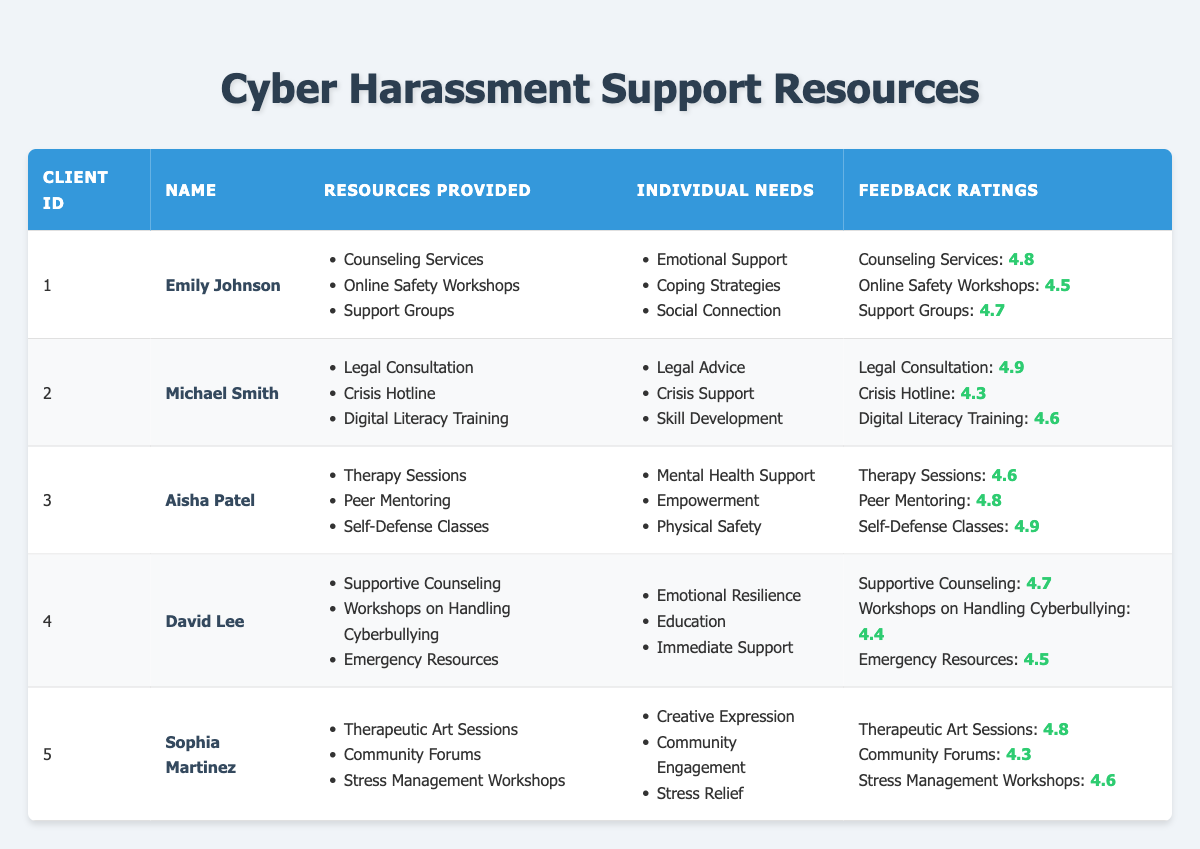What resources were provided to Emily Johnson? Emily Johnson is listed in the table with the resources provided as Counseling Services, Online Safety Workshops, and Support Groups.
Answer: Counseling Services, Online Safety Workshops, Support Groups What was the feedback rating for the Crisis Hotline? The table provides the feedback rating for the Crisis Hotline under Michael Smith's entry as 4.3.
Answer: 4.3 Which client received the highest average feedback rating for their resources? To find the average for each client, calculate the average of feedback ratings for all their resources: Emily (4.67), Michael (4.6), Aisha (4.77), David (4.53), Sophia (4.53). Aisha has the highest average (4.77).
Answer: Aisha Patel Did Sophia Martinez receive any resources focused on stress relief? The table indicates that Sophia received Stress Management Workshops, which relates to stress relief.
Answer: Yes What is the average feedback rating for all resources provided to David Lee? David received feedback ratings for three resources: 4.7, 4.4, and 4.5. To find the average, sum these values (4.7 + 4.4 + 4.5 = 13.6) and divide by 3, resulting in 13.6/3 = 4.53.
Answer: 4.53 Which resource did Aisha Patel rate the highest? Aisha Patel rated Self-Defense Classes highest at 4.9 according to the feedback ratings given in the table.
Answer: Self-Defense Classes How many resources were provided to Michael Smith, and what is the lowest feedback rating among them? Michael received three resources: Legal Consultation, Crisis Hotline, and Digital Literacy Training. The ratings are 4.9, 4.3, and 4.6, respectively, making the lowest rating 4.3 (Crisis Hotline).
Answer: 3 resources; lowest rating is 4.3 Which individual need was ranked highest in feedback rating among all clients? Analyze individual needs based on feedback ratings: Aisha's feedback for Self-Defense Classes (4.9) is the highest among all ratings associated with individual needs.
Answer: Physical Safety (4.9) For which client do the resources align the most with their individual needs? Evaluate alignment: Aisha's needs (Mental Health Support, Empowerment, Physical Safety) have resources (Therapy, Peer Mentoring, Self-Defense) that correspond closely, particularly reflecting on feedback ratings which are high (4.6, 4.8, 4.9).
Answer: Aisha Patel What is the difference between the highest and lowest feedback ratings received by Emily Johnson? Emily's ratings are 4.8, 4.5, and 4.7. The highest is 4.8 (Counseling Services) and the lowest is 4.5 (Online Safety Workshops), leading to a difference of 4.8 - 4.5 = 0.3.
Answer: 0.3 